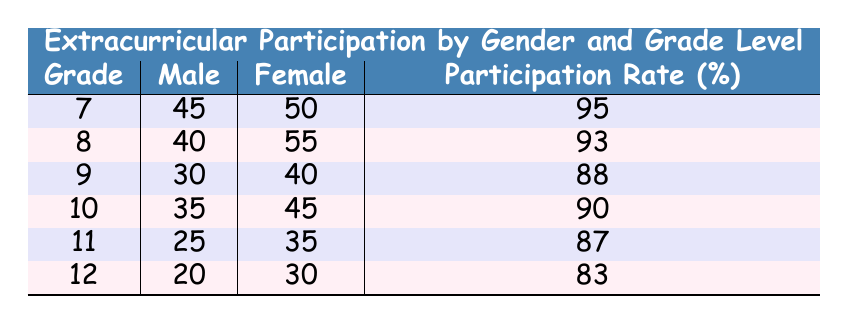What is the total number of males participating in extracurricular activities across all grades? To find the total number of males, I will sum the values in the "Male" column for each grade: 45 + 40 + 30 + 35 + 25 + 20 = 225.
Answer: 225 What is the participation rate for 9th graders? Directly from the table, the participation rate for 9th graders is listed as 88%.
Answer: 88% Is the participation rate for 12th-grade students lower than for 11th-grade students? The participation rate for 12th graders is 83%, and for 11th graders, it is 87%. Since 83% is less than 87%, the statement is true.
Answer: Yes What is the difference in the number of female participants between 8th and 10th graders? The number of female participants in 8th grade is 55 and in 10th grade is 45. The difference is 55 - 45 = 10.
Answer: 10 What is the average number of male participants for grades 7 through 9? I will calculate the average by first summing the male participants for these grades: 45 (7th) + 40 (8th) + 30 (9th) = 115. There are 3 grades, so the average is 115/3 = 38.33.
Answer: 38.33 Are there more female participants in 7th grade than in 11th grade? The number of female participants in 7th grade is 50, and in 11th grade, it is 35. Since 50 is greater than 35, the answer is yes.
Answer: Yes What is the total participation rate for all grades combined? To find the overall participation rate, we add the individual rates: (95 + 93 + 88 + 90 + 87 + 83) = 536. Then, divide by the number of grades (6): 536/6 = 89.33.
Answer: 89.33 What is the sum of all participants in 10th grade? For 10th grade, the number of participants is found by adding males (35) and females (45): 35 + 45 = 80.
Answer: 80 Which grade has the highest number of female participants? By examining the table, the highest number of female participants is in 8th grade, with 55 participants.
Answer: 8th grade 